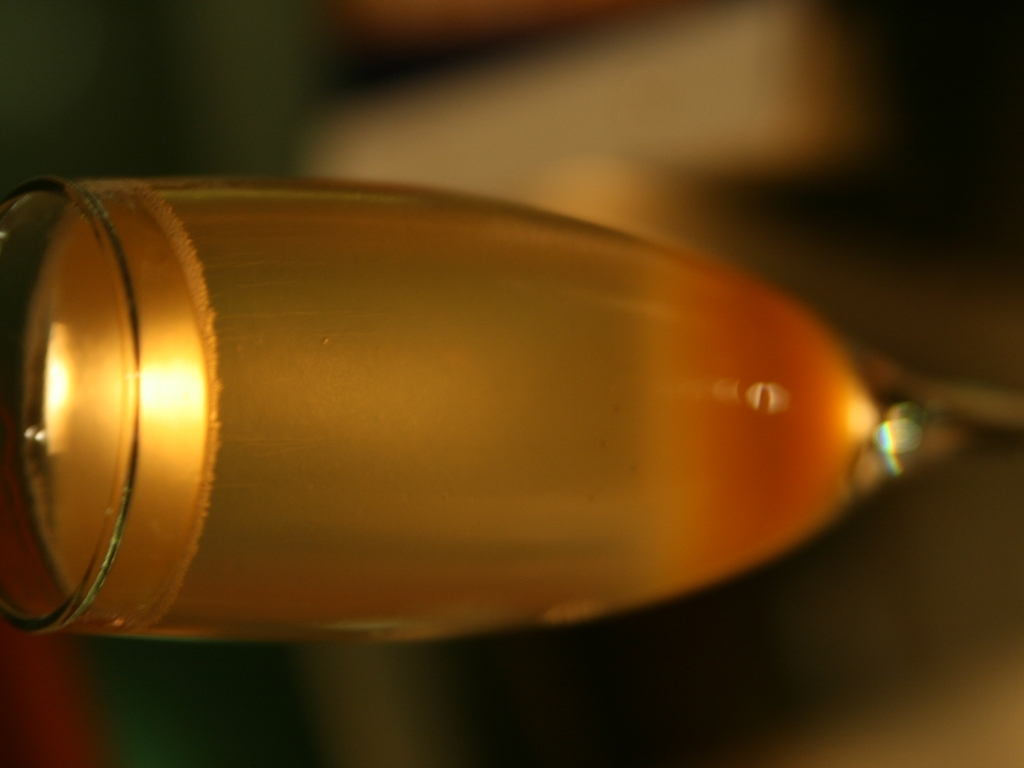Why is it inconvenient to view and understand the image?
A. The lighting is too bright.
B. It has been rotated during presentation.
C. The image is too small.
D. The image is too big. The image presented does not appear to have excessive brightness or inadequate size that would make it inconvenient to view. However, the orientation of the image seems unusual as it is tilted, potentially making the viewing experience nonintuitive. Although it is not fully rotated, the tilt can create a sense of imbalance for the viewer, leading to some inconvenience. 